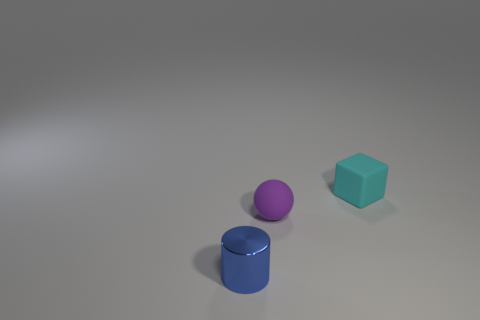What color is the small rubber thing behind the matte object left of the tiny cyan rubber cube?
Make the answer very short. Cyan. Is the material of the small cylinder the same as the small cube?
Ensure brevity in your answer.  No. Are there any tiny green matte objects of the same shape as the tiny purple object?
Your answer should be very brief. No. Do the matte object that is left of the rubber cube and the cube have the same color?
Offer a very short reply. No. Do the matte thing in front of the cyan thing and the thing that is in front of the tiny purple object have the same size?
Provide a short and direct response. Yes. The cyan object that is the same material as the tiny purple sphere is what size?
Offer a very short reply. Small. How many tiny objects are in front of the cyan matte cube and behind the small purple rubber sphere?
Keep it short and to the point. 0. What number of things are either blue cylinders or things on the left side of the small purple ball?
Provide a short and direct response. 1. What is the color of the tiny object that is in front of the purple sphere?
Provide a short and direct response. Blue. How many things are either things that are to the right of the blue thing or big red rubber spheres?
Ensure brevity in your answer.  2. 